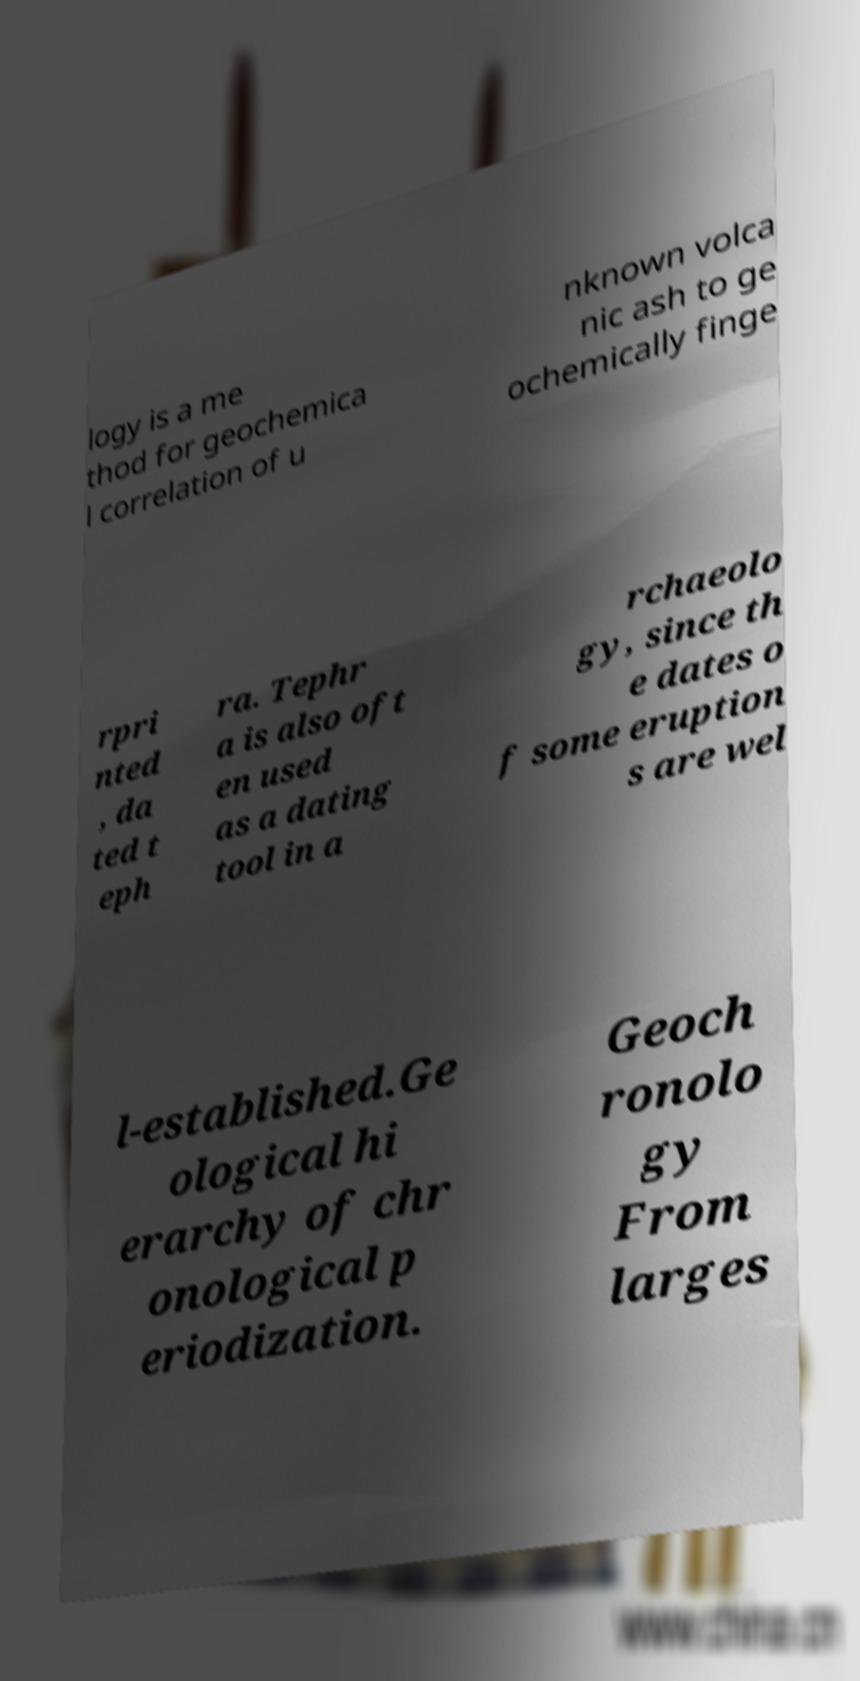Please identify and transcribe the text found in this image. logy is a me thod for geochemica l correlation of u nknown volca nic ash to ge ochemically finge rpri nted , da ted t eph ra. Tephr a is also oft en used as a dating tool in a rchaeolo gy, since th e dates o f some eruption s are wel l-established.Ge ological hi erarchy of chr onological p eriodization. Geoch ronolo gy From larges 